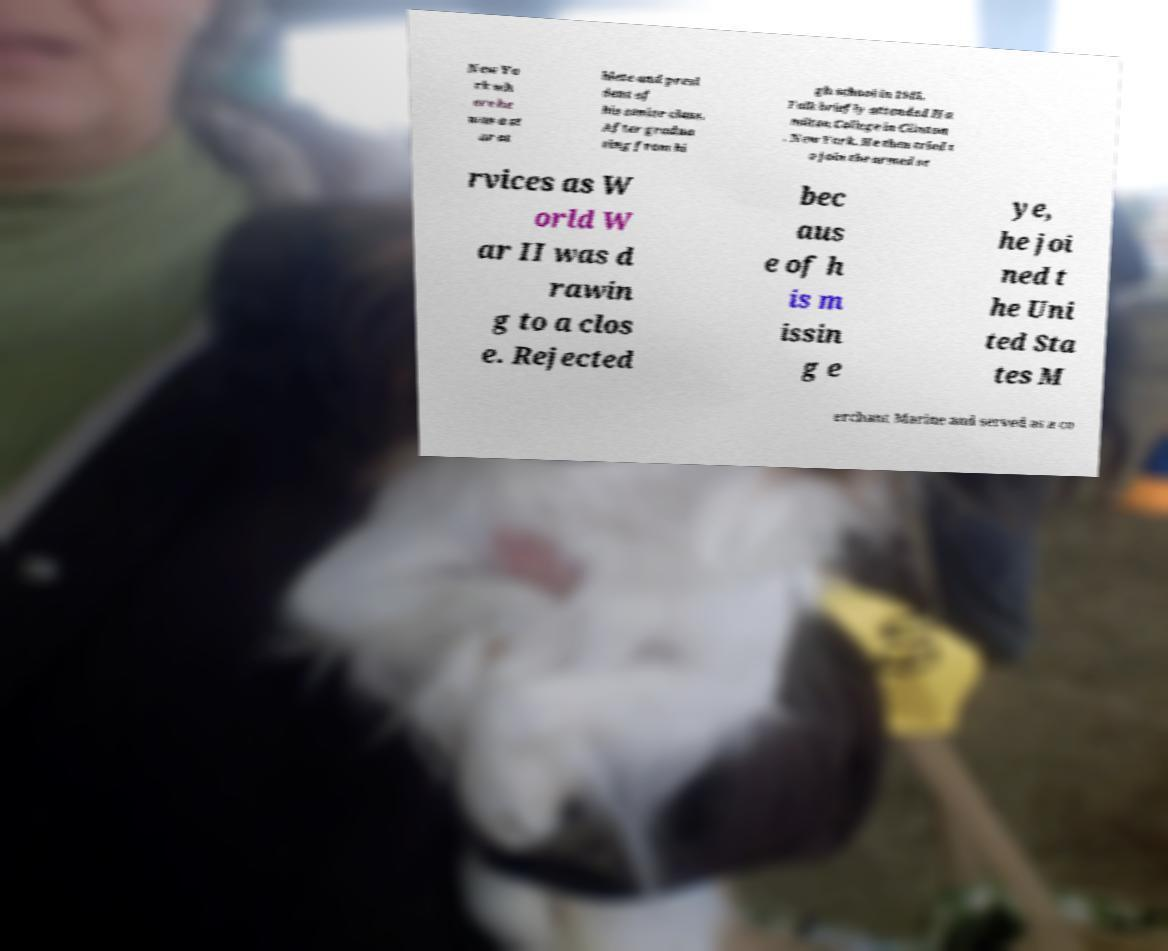What messages or text are displayed in this image? I need them in a readable, typed format. New Yo rk wh ere he was a st ar at hlete and presi dent of his senior class. After gradua ting from hi gh school in 1945, Falk briefly attended Ha milton College in Clinton , New York. He then tried t o join the armed se rvices as W orld W ar II was d rawin g to a clos e. Rejected bec aus e of h is m issin g e ye, he joi ned t he Uni ted Sta tes M erchant Marine and served as a co 